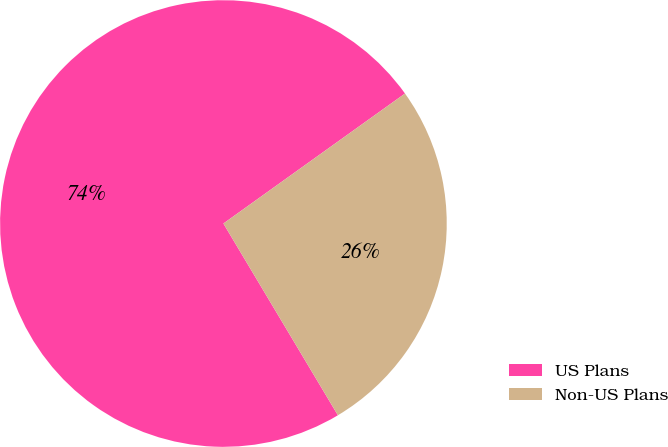Convert chart to OTSL. <chart><loc_0><loc_0><loc_500><loc_500><pie_chart><fcel>US Plans<fcel>Non-US Plans<nl><fcel>73.68%<fcel>26.32%<nl></chart> 